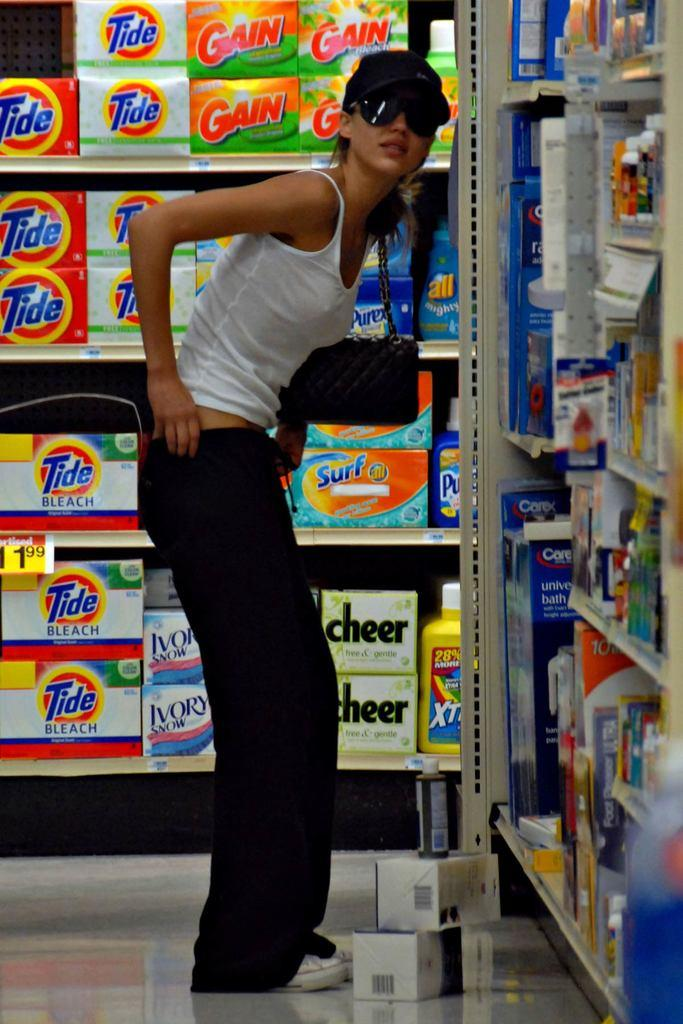<image>
Give a short and clear explanation of the subsequent image. A women wearing sunglasses is standing in front of boxes of tide and gain. 